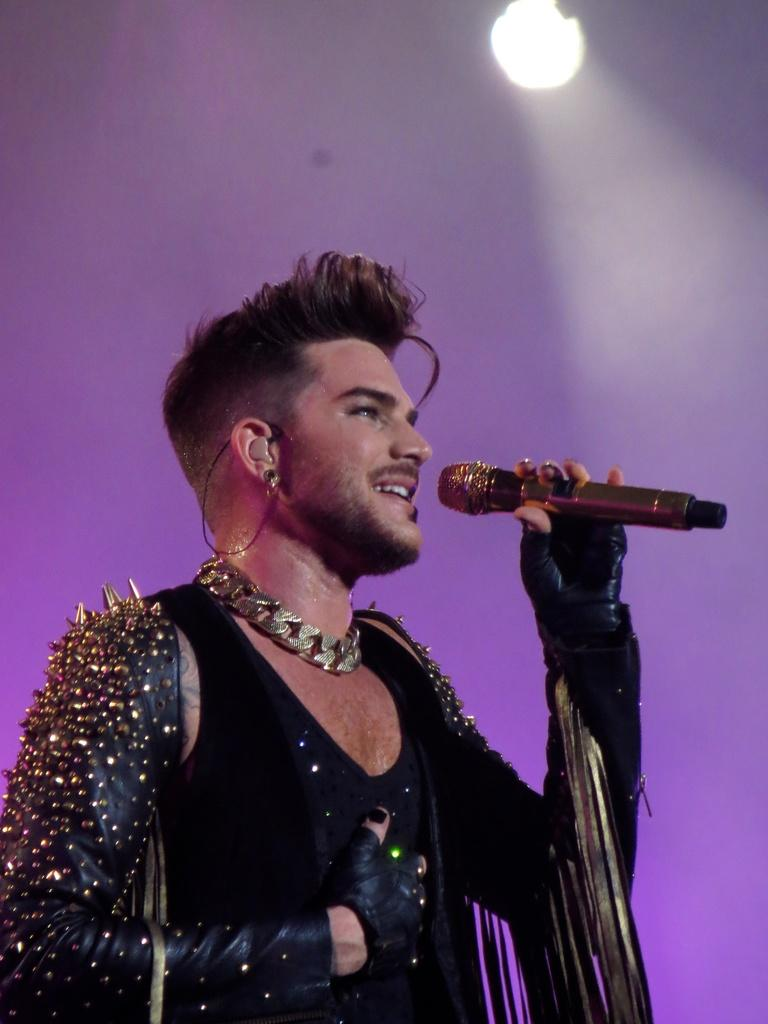What is the main subject of the image? The main subject of the image is a man. What is the man wearing in the image? The man is wearing a black vest and jewellery. What is the man holding in the image? The man is holding a mic. What can be inferred about the man's profession based on the image? The man appears to be a pop star. What is the color of the background in the image? The background of the image is in purple color. How many planes are visible in the image? There are no planes visible in the image. What type of band is the man performing with in the image? The image does not show the man performing with a band; he is holding a mic, but there is no indication of a band. Is the man in the image a farmer? There is no indication in the image that the man is a farmer; he appears to be a pop star. 